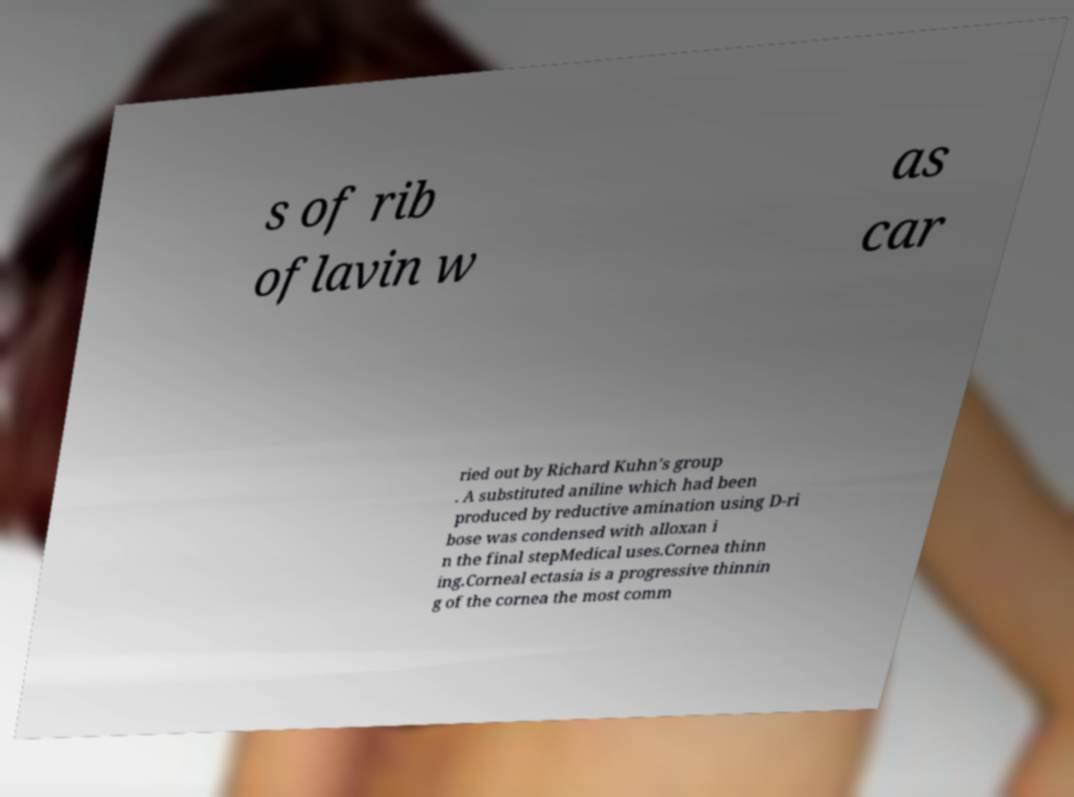Could you extract and type out the text from this image? s of rib oflavin w as car ried out by Richard Kuhn's group . A substituted aniline which had been produced by reductive amination using D-ri bose was condensed with alloxan i n the final stepMedical uses.Cornea thinn ing.Corneal ectasia is a progressive thinnin g of the cornea the most comm 